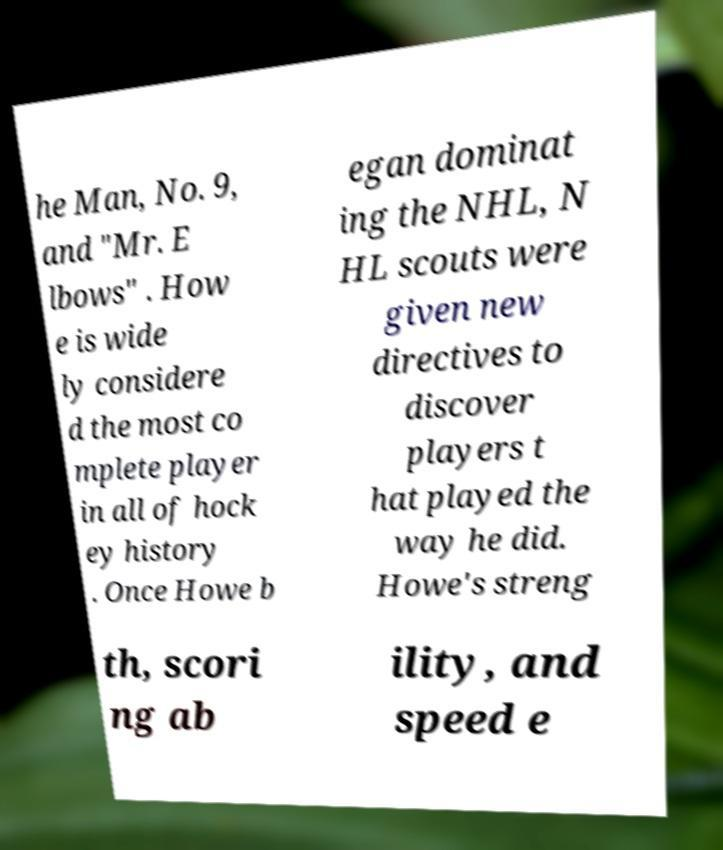Could you assist in decoding the text presented in this image and type it out clearly? he Man, No. 9, and "Mr. E lbows" . How e is wide ly considere d the most co mplete player in all of hock ey history . Once Howe b egan dominat ing the NHL, N HL scouts were given new directives to discover players t hat played the way he did. Howe's streng th, scori ng ab ility, and speed e 